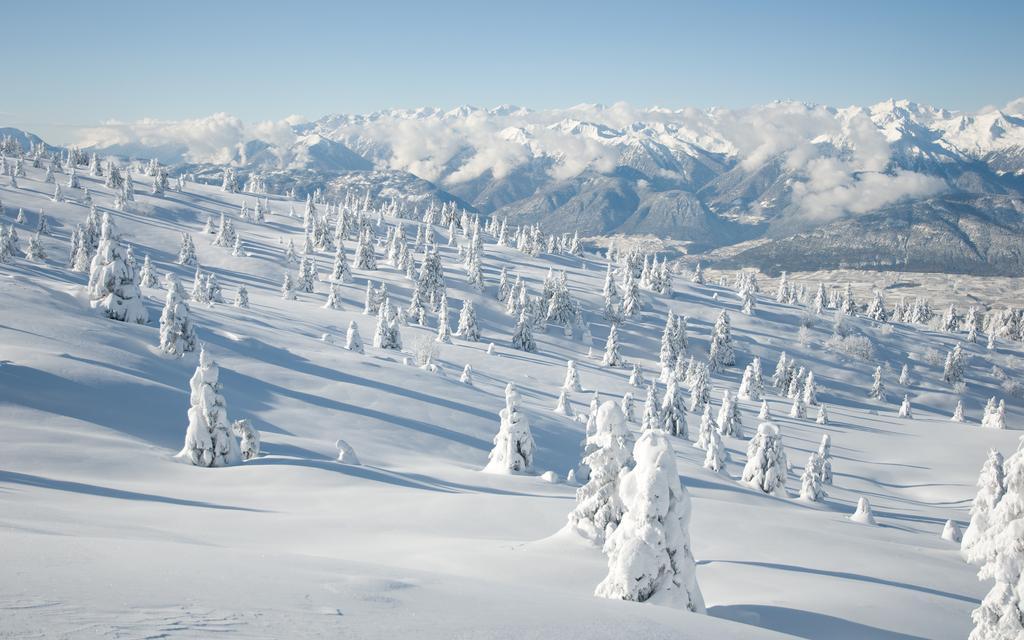Please provide a concise description of this image. In this image I can see trees, mountains and the sky. This image is taken near the ice mountains during a day. 